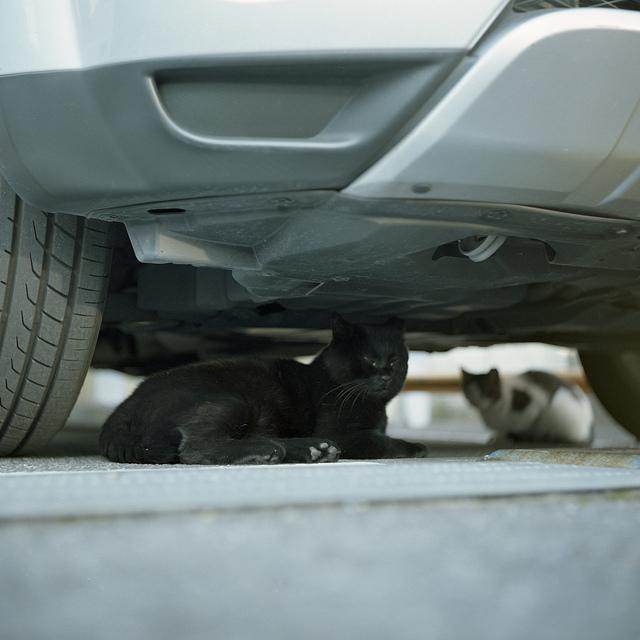Are the cats scared of cars?
Short answer required. No. What is under the car?
Short answer required. Cats. Are the cats hiding?
Give a very brief answer. Yes. 